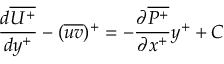<formula> <loc_0><loc_0><loc_500><loc_500>\frac { d \overline { { U ^ { + } } } } { d y ^ { + } } - ( \overline { u v } ) ^ { + } = - \frac { \partial \overline { { P ^ { + } } } } { \partial x ^ { + } } y ^ { + } + C</formula> 